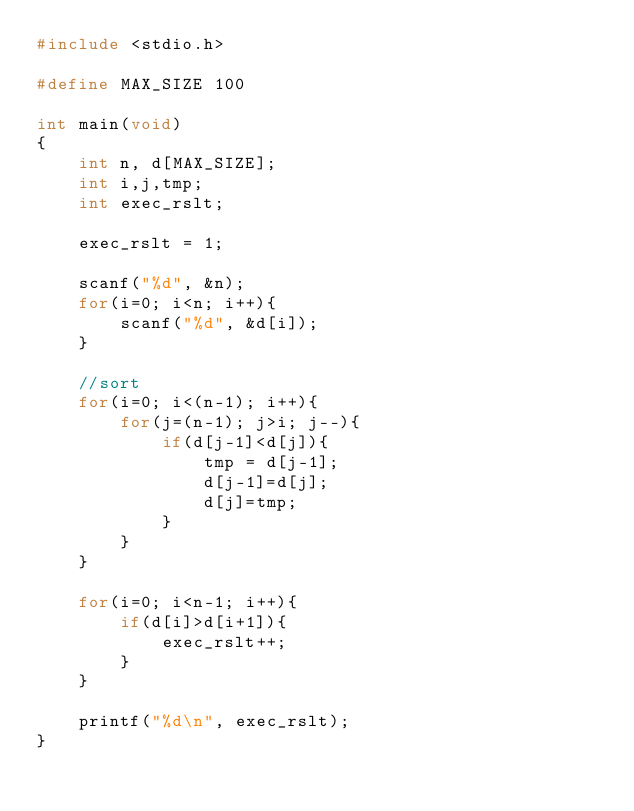<code> <loc_0><loc_0><loc_500><loc_500><_C_>#include <stdio.h>

#define MAX_SIZE 100

int main(void)
{
    int n, d[MAX_SIZE];
    int i,j,tmp;
    int exec_rslt;

    exec_rslt = 1;

    scanf("%d", &n);
    for(i=0; i<n; i++){
        scanf("%d", &d[i]);
    }

    //sort
    for(i=0; i<(n-1); i++){
        for(j=(n-1); j>i; j--){
            if(d[j-1]<d[j]){
                tmp = d[j-1];
                d[j-1]=d[j];
                d[j]=tmp;
            }
        }
    }

    for(i=0; i<n-1; i++){
        if(d[i]>d[i+1]){
            exec_rslt++;
        }
    }

    printf("%d\n", exec_rslt);
}</code> 